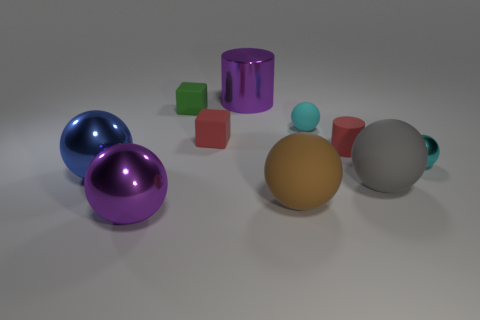Are there more rubber cylinders right of the brown rubber ball than green cubes behind the large purple cylinder?
Offer a very short reply. Yes. Does the small green object have the same shape as the small red object on the left side of the red rubber cylinder?
Your answer should be compact. Yes. How many other objects are there of the same shape as the big gray rubber object?
Your answer should be compact. 5. There is a ball that is behind the large blue shiny ball and left of the red cylinder; what is its color?
Your response must be concise. Cyan. What color is the small matte ball?
Offer a very short reply. Cyan. Are the small red cylinder and the purple object that is behind the brown matte sphere made of the same material?
Offer a very short reply. No. What shape is the tiny cyan object that is the same material as the gray object?
Provide a short and direct response. Sphere. What color is the metal cylinder that is the same size as the blue object?
Offer a terse response. Purple. Do the cylinder that is in front of the cyan rubber ball and the cyan rubber object have the same size?
Ensure brevity in your answer.  Yes. Is the small metallic sphere the same color as the small rubber ball?
Give a very brief answer. Yes. 